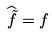<formula> <loc_0><loc_0><loc_500><loc_500>\widehat { \tilde { f } } = f</formula> 